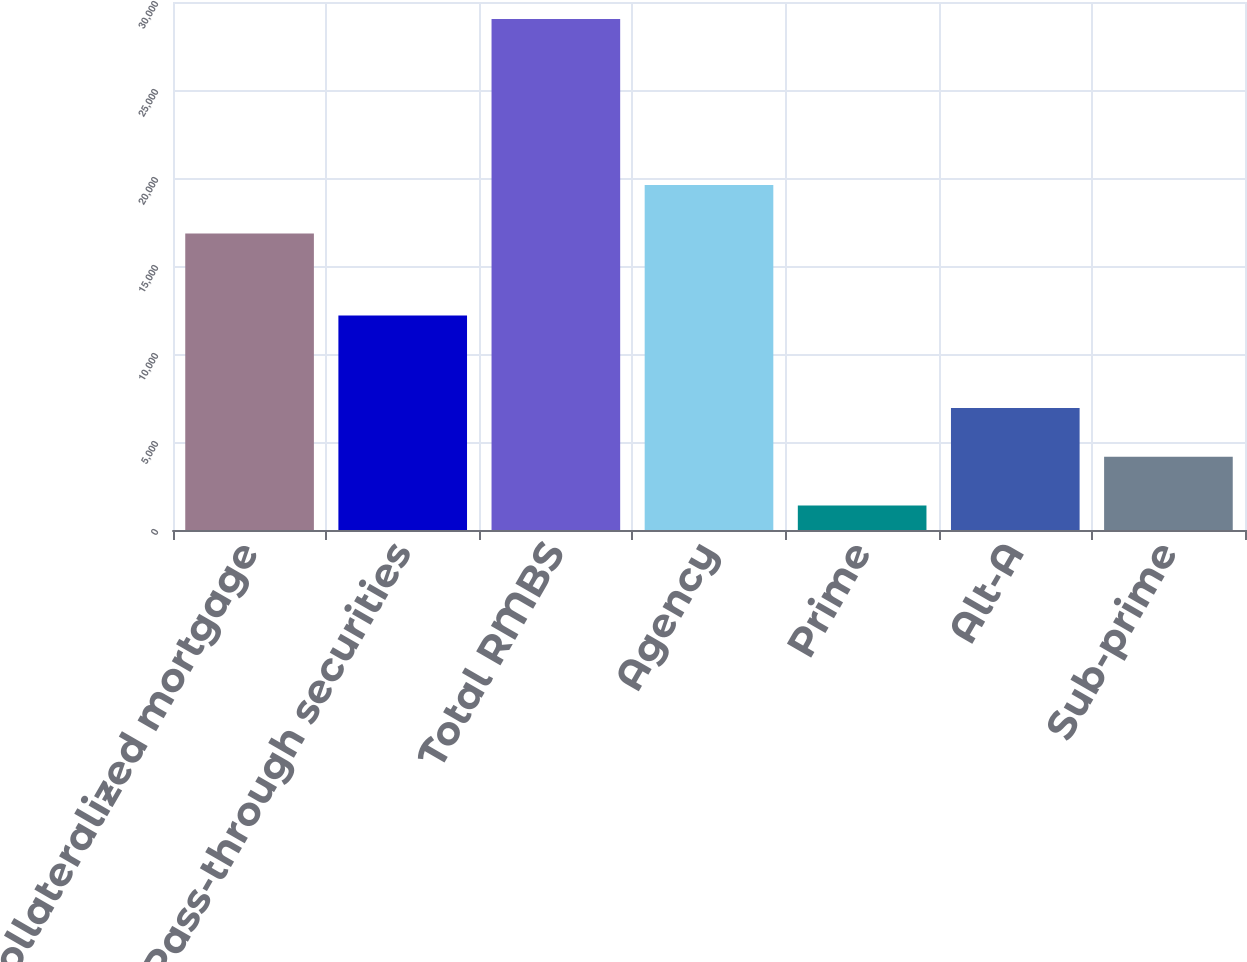Convert chart to OTSL. <chart><loc_0><loc_0><loc_500><loc_500><bar_chart><fcel>Collateralized mortgage<fcel>Pass-through securities<fcel>Total RMBS<fcel>Agency<fcel>Prime<fcel>Alt-A<fcel>Sub-prime<nl><fcel>16842<fcel>12190<fcel>29032<fcel>19605.4<fcel>1398<fcel>6924.8<fcel>4161.4<nl></chart> 